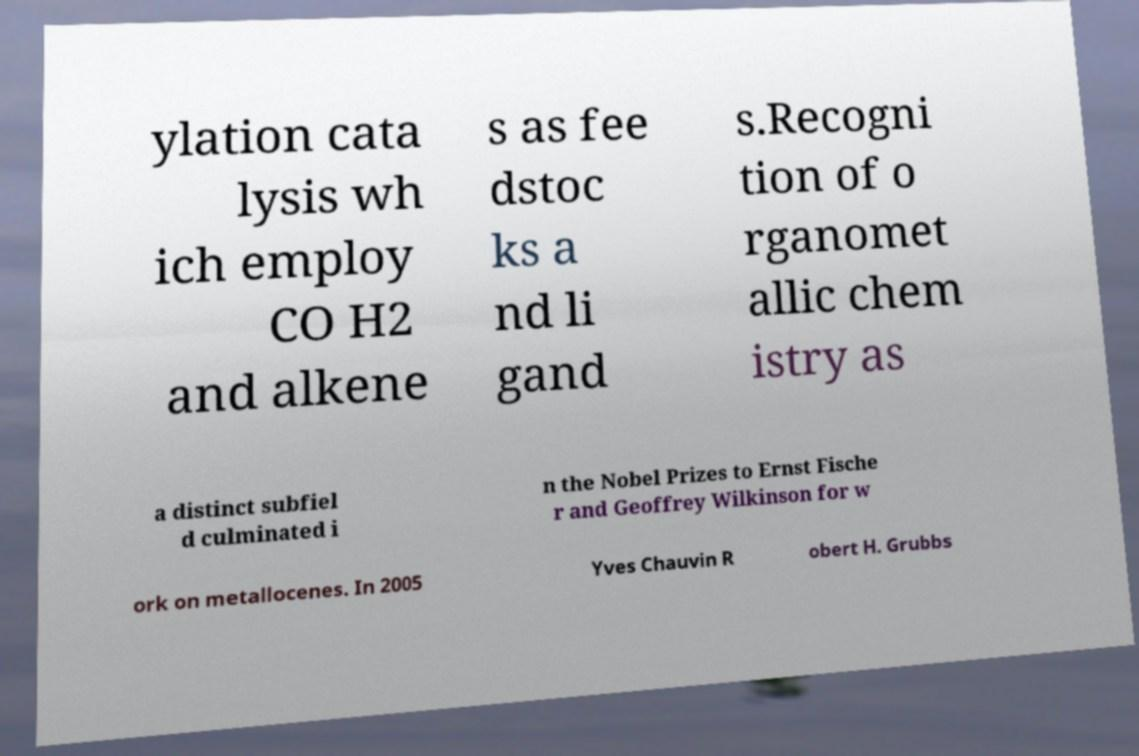What messages or text are displayed in this image? I need them in a readable, typed format. ylation cata lysis wh ich employ CO H2 and alkene s as fee dstoc ks a nd li gand s.Recogni tion of o rganomet allic chem istry as a distinct subfiel d culminated i n the Nobel Prizes to Ernst Fische r and Geoffrey Wilkinson for w ork on metallocenes. In 2005 Yves Chauvin R obert H. Grubbs 